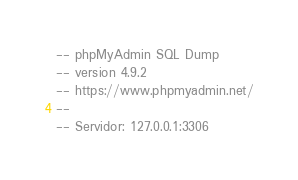Convert code to text. <code><loc_0><loc_0><loc_500><loc_500><_SQL_>-- phpMyAdmin SQL Dump
-- version 4.9.2
-- https://www.phpmyadmin.net/
--
-- Servidor: 127.0.0.1:3306</code> 